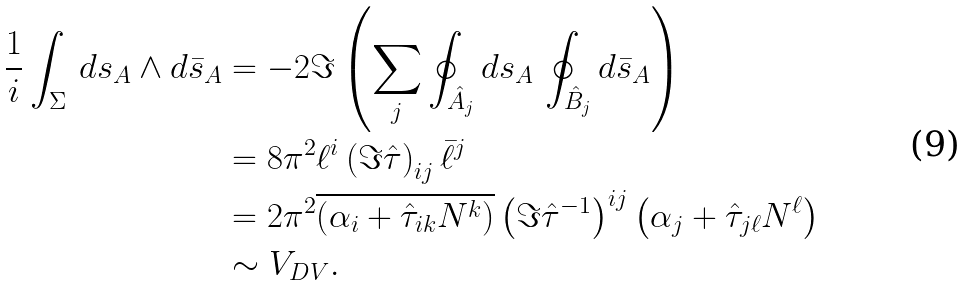Convert formula to latex. <formula><loc_0><loc_0><loc_500><loc_500>\frac { 1 } { i } \int _ { \Sigma } \, d s _ { A } \wedge d \bar { s } _ { A } & = - 2 \Im \left ( \sum _ { j } \oint _ { \hat { A } _ { j } } d s _ { A } \, \oint _ { \hat { B } _ { j } } d \bar { s } _ { A } \right ) \\ & = 8 \pi ^ { 2 } \ell ^ { i } \left ( \Im \hat { \tau } \right ) _ { i j } \bar { \ell } ^ { j } \\ & = 2 \pi ^ { 2 } \overline { \left ( \alpha _ { i } + \hat { \tau } _ { i k } N ^ { k } \right ) } \left ( \Im \hat { \tau } ^ { - 1 } \right ) ^ { i j } \left ( \alpha _ { j } + \hat { \tau } _ { j \ell } N ^ { \ell } \right ) \\ & \sim V _ { D V } .</formula> 